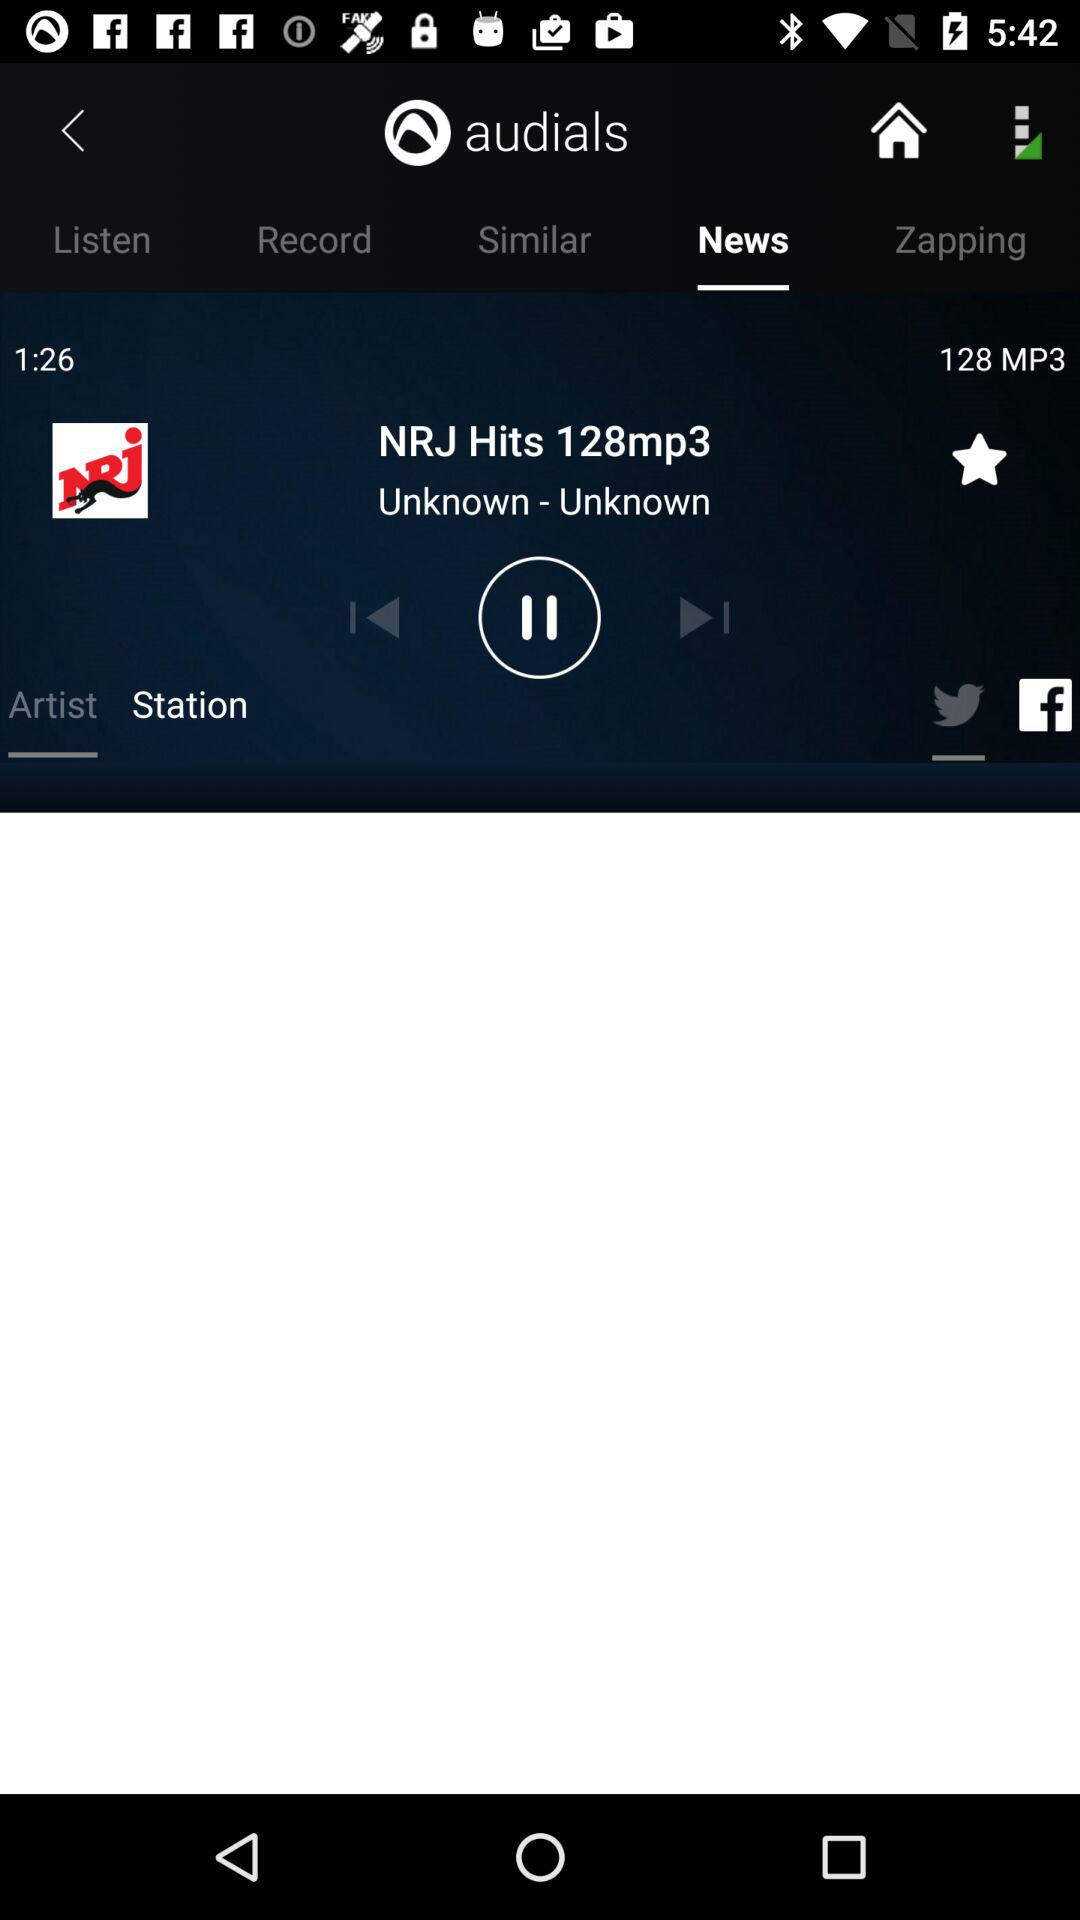Which song is currently playing? The currently playing song is "NRJ Hits 128mp3". 